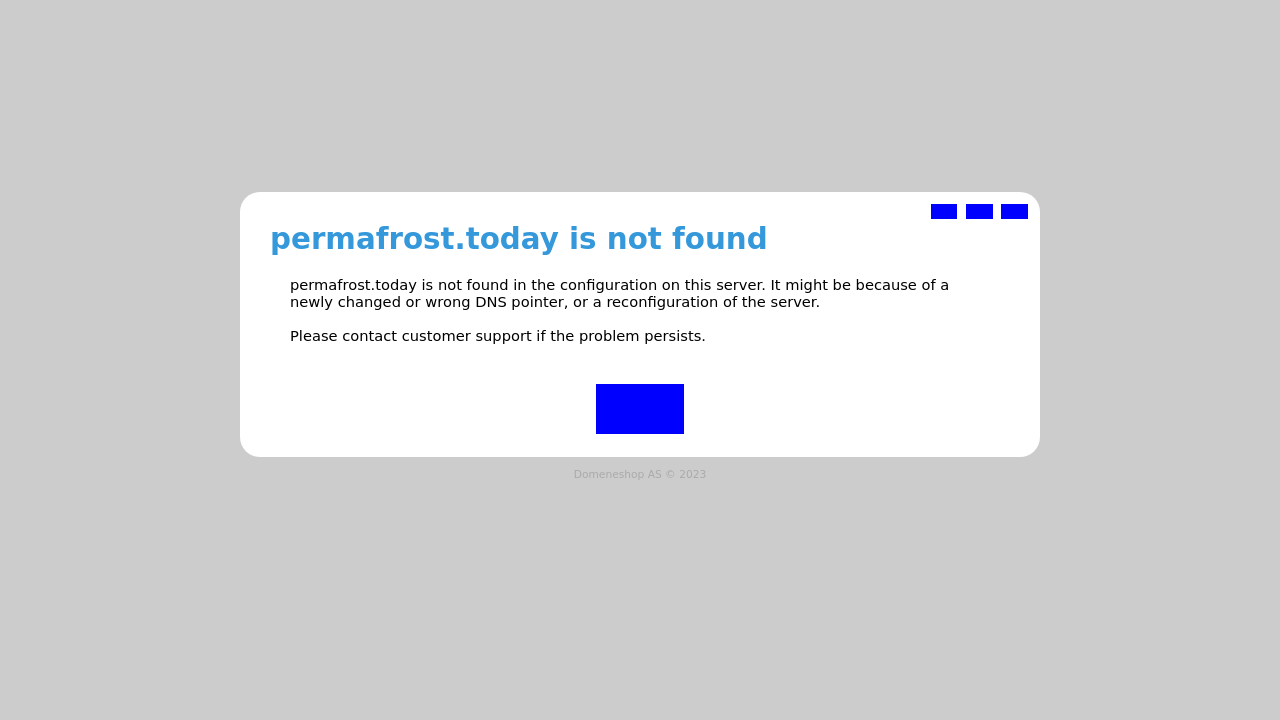Can you explain what might cause a 'site not found' error as displayed in this image, and how to troubleshoot it? The 'site not found' error usually indicates a DNS resolution issue or that the domain isn't properly configured on the server. To troubleshoot, first check the domain name's DNS settings and ensure they're pointing to the correct IP address. If the settings are correct, verify the server configuration to ensure your domain is set up correctly. Additionally, check with the hosting provider to see if there are any server-related issues. Refreshing or clearing your DNS cache on your device might also help resolve the issue. 